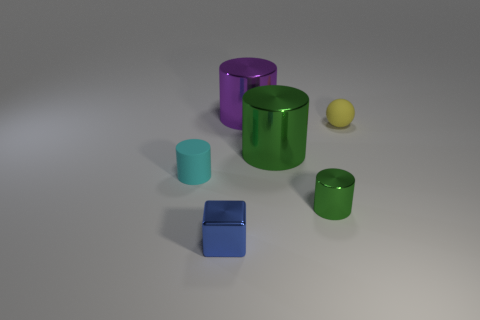Which objects in the image are likely to weigh more and why? The purple cylinder and the larger green cylinder likely weigh more due to their size when compared to the other objects in the image. Their materials appear dense and, assuming they are made of metal, the larger volume would result in greater mass. 